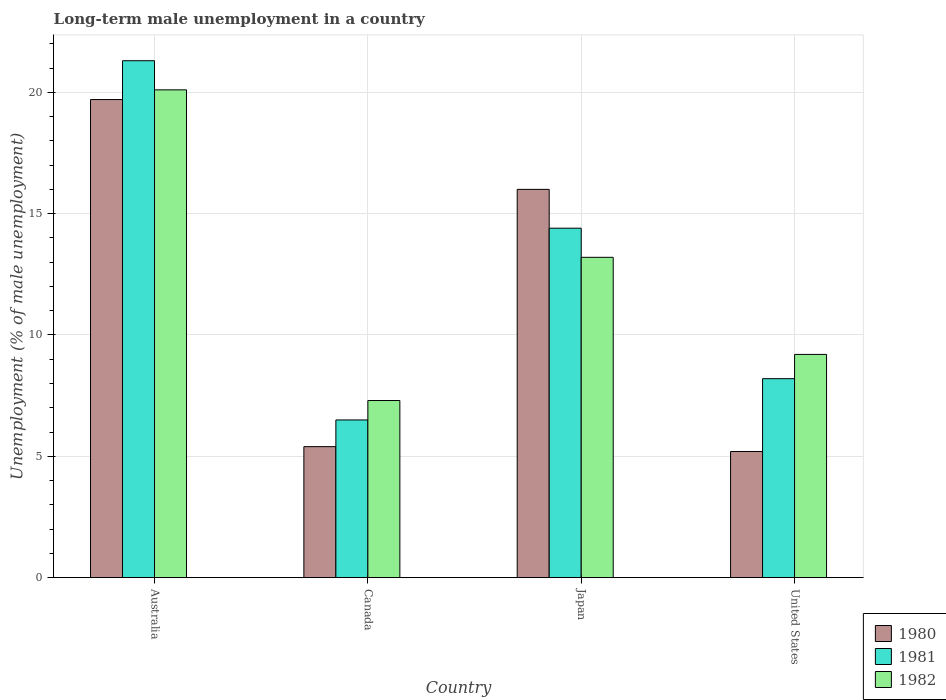Are the number of bars per tick equal to the number of legend labels?
Make the answer very short. Yes. Are the number of bars on each tick of the X-axis equal?
Keep it short and to the point. Yes. How many bars are there on the 1st tick from the left?
Keep it short and to the point. 3. In how many cases, is the number of bars for a given country not equal to the number of legend labels?
Your response must be concise. 0. What is the percentage of long-term unemployed male population in 1981 in United States?
Make the answer very short. 8.2. Across all countries, what is the maximum percentage of long-term unemployed male population in 1982?
Your response must be concise. 20.1. Across all countries, what is the minimum percentage of long-term unemployed male population in 1981?
Offer a terse response. 6.5. In which country was the percentage of long-term unemployed male population in 1980 minimum?
Ensure brevity in your answer.  United States. What is the total percentage of long-term unemployed male population in 1980 in the graph?
Give a very brief answer. 46.3. What is the difference between the percentage of long-term unemployed male population in 1981 in Japan and that in United States?
Ensure brevity in your answer.  6.2. What is the difference between the percentage of long-term unemployed male population in 1982 in Japan and the percentage of long-term unemployed male population in 1980 in United States?
Provide a succinct answer. 8. What is the average percentage of long-term unemployed male population in 1982 per country?
Keep it short and to the point. 12.45. What is the difference between the percentage of long-term unemployed male population of/in 1982 and percentage of long-term unemployed male population of/in 1981 in United States?
Provide a short and direct response. 1. In how many countries, is the percentage of long-term unemployed male population in 1982 greater than 17 %?
Offer a very short reply. 1. What is the ratio of the percentage of long-term unemployed male population in 1980 in Australia to that in Japan?
Offer a terse response. 1.23. What is the difference between the highest and the second highest percentage of long-term unemployed male population in 1980?
Keep it short and to the point. -3.7. What is the difference between the highest and the lowest percentage of long-term unemployed male population in 1980?
Your response must be concise. 14.5. In how many countries, is the percentage of long-term unemployed male population in 1982 greater than the average percentage of long-term unemployed male population in 1982 taken over all countries?
Your response must be concise. 2. Is the sum of the percentage of long-term unemployed male population in 1982 in Australia and Canada greater than the maximum percentage of long-term unemployed male population in 1981 across all countries?
Keep it short and to the point. Yes. What does the 1st bar from the left in Japan represents?
Your answer should be very brief. 1980. Are all the bars in the graph horizontal?
Your answer should be compact. No. How many countries are there in the graph?
Provide a succinct answer. 4. What is the difference between two consecutive major ticks on the Y-axis?
Your response must be concise. 5. How many legend labels are there?
Make the answer very short. 3. How are the legend labels stacked?
Provide a short and direct response. Vertical. What is the title of the graph?
Offer a very short reply. Long-term male unemployment in a country. What is the label or title of the X-axis?
Your response must be concise. Country. What is the label or title of the Y-axis?
Your answer should be very brief. Unemployment (% of male unemployment). What is the Unemployment (% of male unemployment) in 1980 in Australia?
Offer a terse response. 19.7. What is the Unemployment (% of male unemployment) in 1981 in Australia?
Give a very brief answer. 21.3. What is the Unemployment (% of male unemployment) of 1982 in Australia?
Offer a terse response. 20.1. What is the Unemployment (% of male unemployment) in 1980 in Canada?
Provide a succinct answer. 5.4. What is the Unemployment (% of male unemployment) of 1981 in Canada?
Provide a short and direct response. 6.5. What is the Unemployment (% of male unemployment) of 1982 in Canada?
Keep it short and to the point. 7.3. What is the Unemployment (% of male unemployment) in 1980 in Japan?
Keep it short and to the point. 16. What is the Unemployment (% of male unemployment) in 1981 in Japan?
Keep it short and to the point. 14.4. What is the Unemployment (% of male unemployment) of 1982 in Japan?
Your answer should be very brief. 13.2. What is the Unemployment (% of male unemployment) of 1980 in United States?
Keep it short and to the point. 5.2. What is the Unemployment (% of male unemployment) of 1981 in United States?
Offer a very short reply. 8.2. What is the Unemployment (% of male unemployment) in 1982 in United States?
Provide a succinct answer. 9.2. Across all countries, what is the maximum Unemployment (% of male unemployment) in 1980?
Make the answer very short. 19.7. Across all countries, what is the maximum Unemployment (% of male unemployment) in 1981?
Offer a very short reply. 21.3. Across all countries, what is the maximum Unemployment (% of male unemployment) in 1982?
Your answer should be compact. 20.1. Across all countries, what is the minimum Unemployment (% of male unemployment) in 1980?
Your answer should be compact. 5.2. Across all countries, what is the minimum Unemployment (% of male unemployment) in 1982?
Make the answer very short. 7.3. What is the total Unemployment (% of male unemployment) of 1980 in the graph?
Your answer should be very brief. 46.3. What is the total Unemployment (% of male unemployment) of 1981 in the graph?
Make the answer very short. 50.4. What is the total Unemployment (% of male unemployment) in 1982 in the graph?
Your answer should be very brief. 49.8. What is the difference between the Unemployment (% of male unemployment) in 1980 in Australia and that in Canada?
Your response must be concise. 14.3. What is the difference between the Unemployment (% of male unemployment) in 1982 in Australia and that in Canada?
Make the answer very short. 12.8. What is the difference between the Unemployment (% of male unemployment) of 1981 in Australia and that in Japan?
Make the answer very short. 6.9. What is the difference between the Unemployment (% of male unemployment) of 1981 in Australia and that in United States?
Your answer should be very brief. 13.1. What is the difference between the Unemployment (% of male unemployment) in 1982 in Australia and that in United States?
Ensure brevity in your answer.  10.9. What is the difference between the Unemployment (% of male unemployment) in 1980 in Canada and that in Japan?
Provide a short and direct response. -10.6. What is the difference between the Unemployment (% of male unemployment) in 1981 in Canada and that in Japan?
Keep it short and to the point. -7.9. What is the difference between the Unemployment (% of male unemployment) in 1982 in Canada and that in Japan?
Make the answer very short. -5.9. What is the difference between the Unemployment (% of male unemployment) in 1981 in Canada and that in United States?
Your answer should be compact. -1.7. What is the difference between the Unemployment (% of male unemployment) of 1980 in Japan and that in United States?
Your answer should be compact. 10.8. What is the difference between the Unemployment (% of male unemployment) in 1981 in Japan and that in United States?
Your answer should be very brief. 6.2. What is the difference between the Unemployment (% of male unemployment) in 1980 in Australia and the Unemployment (% of male unemployment) in 1981 in Canada?
Offer a very short reply. 13.2. What is the difference between the Unemployment (% of male unemployment) of 1981 in Australia and the Unemployment (% of male unemployment) of 1982 in Canada?
Give a very brief answer. 14. What is the difference between the Unemployment (% of male unemployment) in 1980 in Australia and the Unemployment (% of male unemployment) in 1981 in Japan?
Provide a short and direct response. 5.3. What is the difference between the Unemployment (% of male unemployment) in 1980 in Australia and the Unemployment (% of male unemployment) in 1982 in Japan?
Provide a short and direct response. 6.5. What is the difference between the Unemployment (% of male unemployment) of 1980 in Australia and the Unemployment (% of male unemployment) of 1981 in United States?
Your answer should be compact. 11.5. What is the difference between the Unemployment (% of male unemployment) in 1980 in Canada and the Unemployment (% of male unemployment) in 1981 in Japan?
Provide a succinct answer. -9. What is the difference between the Unemployment (% of male unemployment) of 1980 in Canada and the Unemployment (% of male unemployment) of 1982 in Japan?
Provide a short and direct response. -7.8. What is the difference between the Unemployment (% of male unemployment) in 1981 in Canada and the Unemployment (% of male unemployment) in 1982 in Japan?
Keep it short and to the point. -6.7. What is the difference between the Unemployment (% of male unemployment) in 1980 in Canada and the Unemployment (% of male unemployment) in 1982 in United States?
Your answer should be very brief. -3.8. What is the difference between the Unemployment (% of male unemployment) in 1980 in Japan and the Unemployment (% of male unemployment) in 1981 in United States?
Offer a very short reply. 7.8. What is the difference between the Unemployment (% of male unemployment) of 1981 in Japan and the Unemployment (% of male unemployment) of 1982 in United States?
Offer a terse response. 5.2. What is the average Unemployment (% of male unemployment) of 1980 per country?
Offer a very short reply. 11.57. What is the average Unemployment (% of male unemployment) in 1982 per country?
Keep it short and to the point. 12.45. What is the difference between the Unemployment (% of male unemployment) in 1980 and Unemployment (% of male unemployment) in 1981 in Australia?
Provide a succinct answer. -1.6. What is the difference between the Unemployment (% of male unemployment) of 1980 and Unemployment (% of male unemployment) of 1982 in Canada?
Make the answer very short. -1.9. What is the difference between the Unemployment (% of male unemployment) in 1981 and Unemployment (% of male unemployment) in 1982 in Canada?
Provide a succinct answer. -0.8. What is the difference between the Unemployment (% of male unemployment) in 1980 and Unemployment (% of male unemployment) in 1981 in Japan?
Offer a terse response. 1.6. What is the difference between the Unemployment (% of male unemployment) in 1980 and Unemployment (% of male unemployment) in 1982 in Japan?
Provide a short and direct response. 2.8. What is the difference between the Unemployment (% of male unemployment) in 1980 and Unemployment (% of male unemployment) in 1981 in United States?
Ensure brevity in your answer.  -3. What is the difference between the Unemployment (% of male unemployment) in 1980 and Unemployment (% of male unemployment) in 1982 in United States?
Make the answer very short. -4. What is the difference between the Unemployment (% of male unemployment) of 1981 and Unemployment (% of male unemployment) of 1982 in United States?
Your answer should be compact. -1. What is the ratio of the Unemployment (% of male unemployment) of 1980 in Australia to that in Canada?
Keep it short and to the point. 3.65. What is the ratio of the Unemployment (% of male unemployment) of 1981 in Australia to that in Canada?
Your answer should be compact. 3.28. What is the ratio of the Unemployment (% of male unemployment) of 1982 in Australia to that in Canada?
Make the answer very short. 2.75. What is the ratio of the Unemployment (% of male unemployment) of 1980 in Australia to that in Japan?
Provide a succinct answer. 1.23. What is the ratio of the Unemployment (% of male unemployment) of 1981 in Australia to that in Japan?
Your response must be concise. 1.48. What is the ratio of the Unemployment (% of male unemployment) in 1982 in Australia to that in Japan?
Your answer should be compact. 1.52. What is the ratio of the Unemployment (% of male unemployment) of 1980 in Australia to that in United States?
Give a very brief answer. 3.79. What is the ratio of the Unemployment (% of male unemployment) of 1981 in Australia to that in United States?
Give a very brief answer. 2.6. What is the ratio of the Unemployment (% of male unemployment) of 1982 in Australia to that in United States?
Provide a succinct answer. 2.18. What is the ratio of the Unemployment (% of male unemployment) in 1980 in Canada to that in Japan?
Your response must be concise. 0.34. What is the ratio of the Unemployment (% of male unemployment) of 1981 in Canada to that in Japan?
Provide a succinct answer. 0.45. What is the ratio of the Unemployment (% of male unemployment) in 1982 in Canada to that in Japan?
Keep it short and to the point. 0.55. What is the ratio of the Unemployment (% of male unemployment) in 1981 in Canada to that in United States?
Your answer should be very brief. 0.79. What is the ratio of the Unemployment (% of male unemployment) of 1982 in Canada to that in United States?
Offer a very short reply. 0.79. What is the ratio of the Unemployment (% of male unemployment) in 1980 in Japan to that in United States?
Keep it short and to the point. 3.08. What is the ratio of the Unemployment (% of male unemployment) of 1981 in Japan to that in United States?
Offer a very short reply. 1.76. What is the ratio of the Unemployment (% of male unemployment) in 1982 in Japan to that in United States?
Offer a terse response. 1.43. What is the difference between the highest and the second highest Unemployment (% of male unemployment) of 1982?
Your answer should be compact. 6.9. What is the difference between the highest and the lowest Unemployment (% of male unemployment) in 1980?
Your answer should be compact. 14.5. 